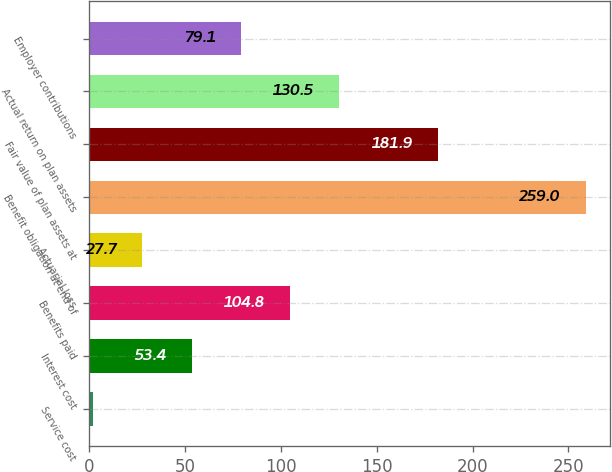Convert chart. <chart><loc_0><loc_0><loc_500><loc_500><bar_chart><fcel>Service cost<fcel>Interest cost<fcel>Benefits paid<fcel>Actuarial loss<fcel>Benefit obligation at end of<fcel>Fair value of plan assets at<fcel>Actual return on plan assets<fcel>Employer contributions<nl><fcel>2<fcel>53.4<fcel>104.8<fcel>27.7<fcel>259<fcel>181.9<fcel>130.5<fcel>79.1<nl></chart> 